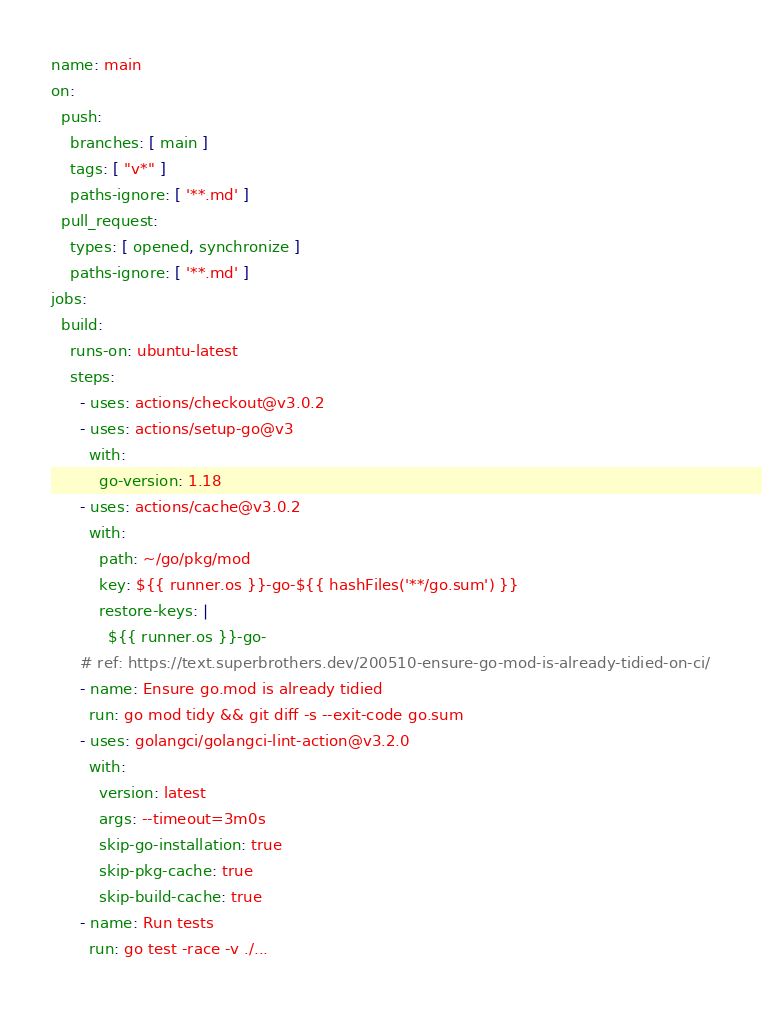<code> <loc_0><loc_0><loc_500><loc_500><_YAML_>name: main
on:
  push:
    branches: [ main ]
    tags: [ "v*" ]
    paths-ignore: [ '**.md' ]
  pull_request:
    types: [ opened, synchronize ]
    paths-ignore: [ '**.md' ]
jobs:
  build:
    runs-on: ubuntu-latest
    steps:
      - uses: actions/checkout@v3.0.2
      - uses: actions/setup-go@v3
        with:
          go-version: 1.18
      - uses: actions/cache@v3.0.2
        with:
          path: ~/go/pkg/mod
          key: ${{ runner.os }}-go-${{ hashFiles('**/go.sum') }}
          restore-keys: |
            ${{ runner.os }}-go-
      # ref: https://text.superbrothers.dev/200510-ensure-go-mod-is-already-tidied-on-ci/
      - name: Ensure go.mod is already tidied
        run: go mod tidy && git diff -s --exit-code go.sum
      - uses: golangci/golangci-lint-action@v3.2.0
        with:
          version: latest
          args: --timeout=3m0s
          skip-go-installation: true
          skip-pkg-cache: true
          skip-build-cache: true
      - name: Run tests
        run: go test -race -v ./...
</code> 